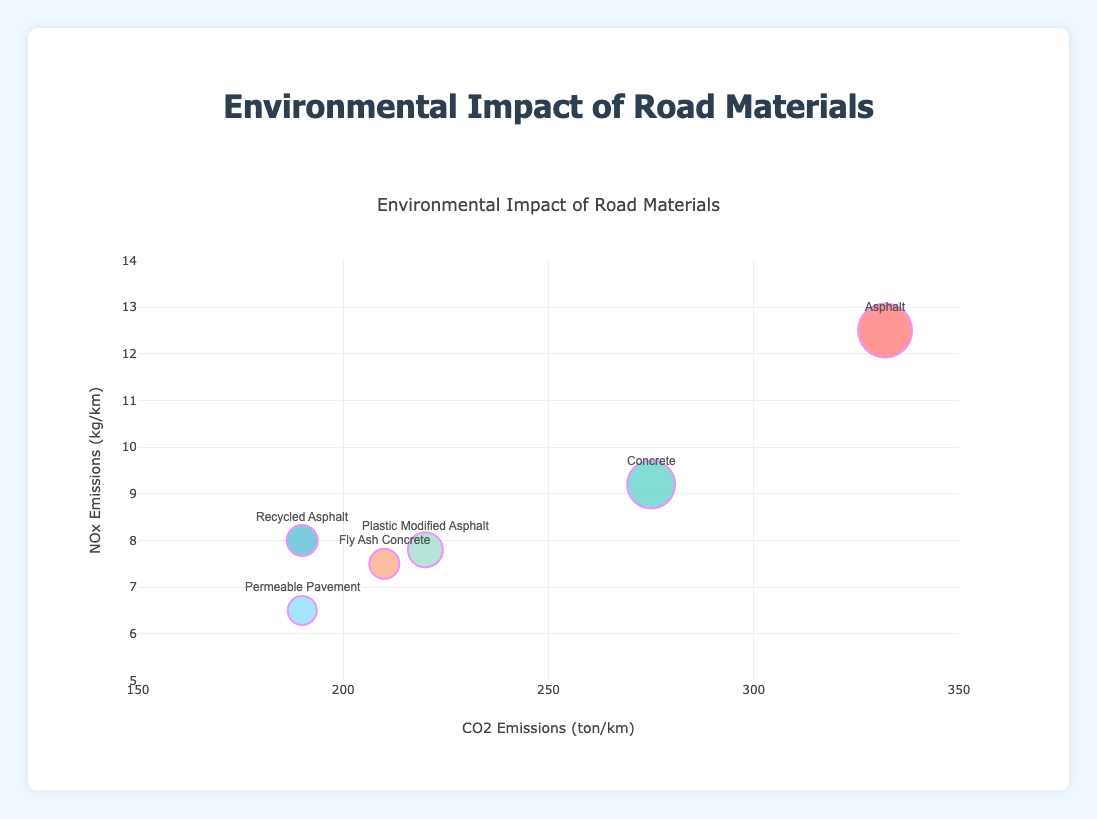What is the title of the bubble chart? The title of the chart is usually placed at the top of the figure. In this case, the title should give an overall idea of what the chart is about.
Answer: Environmental Impact of Road Materials How many different materials are compared in this bubble chart? The number of different materials can be determined by counting the distinct data points or bubbles represented by unique text labels on the chart.
Answer: 6 Which material has the highest CO2 emissions? By looking at the x-axis, which represents CO2 emissions, we can see that the bubble farthest to the right represents the material with the highest CO2 emissions.
Answer: Asphalt Between Fly Ash Concrete and Plastic Modified Asphalt, which material has lower NOx emissions? Compare the y-axis values (NOx emissions) of the two materials by finding their corresponding bubbles and checking their positions. The one with a lower y-value has lower NOx emissions.
Answer: Fly Ash Concrete Which material has the smallest bubble size in the chart? The size of the bubbles represents Particulate Matter emissions. The smallest bubble indicates the material with the least emissions.
Answer: Permeable Pavement What are the CO2 and NOx emissions for Recycled Asphalt? To find these values, locate the bubble for Recycled Asphalt and read off its position on the x-axis (CO2 emissions) and y-axis (NOx emissions).
Answer: 190 ton/km CO2, 8 kg/km NOx Which material has the second-highest amount of particulate matter emissions, as indicated by bubble size? Compare the sizes of the bubbles and identify the one that is the second largest.
Answer: Concrete What is the overall trend observed between CO2 and NOx emissions? Examine the general pattern of the bubbles in terms of their x and y coordinates to identify whether there is a positive or negative correlation, or if there is no clear pattern.
Answer: Positive correlation If you want the least environmental impact in terms of all three emissions (CO2, NOx, and particulate matter), which material should you choose? Identify the bubble with the lowest values on the x-axis and y-axis and the smallest size, which represents the least emissions across all three measures.
Answer: Permeable Pavement Are there any materials with similar CO2 emissions but different NOx emissions? If so, name them. Look for bubbles that align closely along the x-axis (CO2 emissions) but differ along the y-axis (NOx emissions).
Answer: Fly Ash Concrete and Plastic Modified Asphalt 